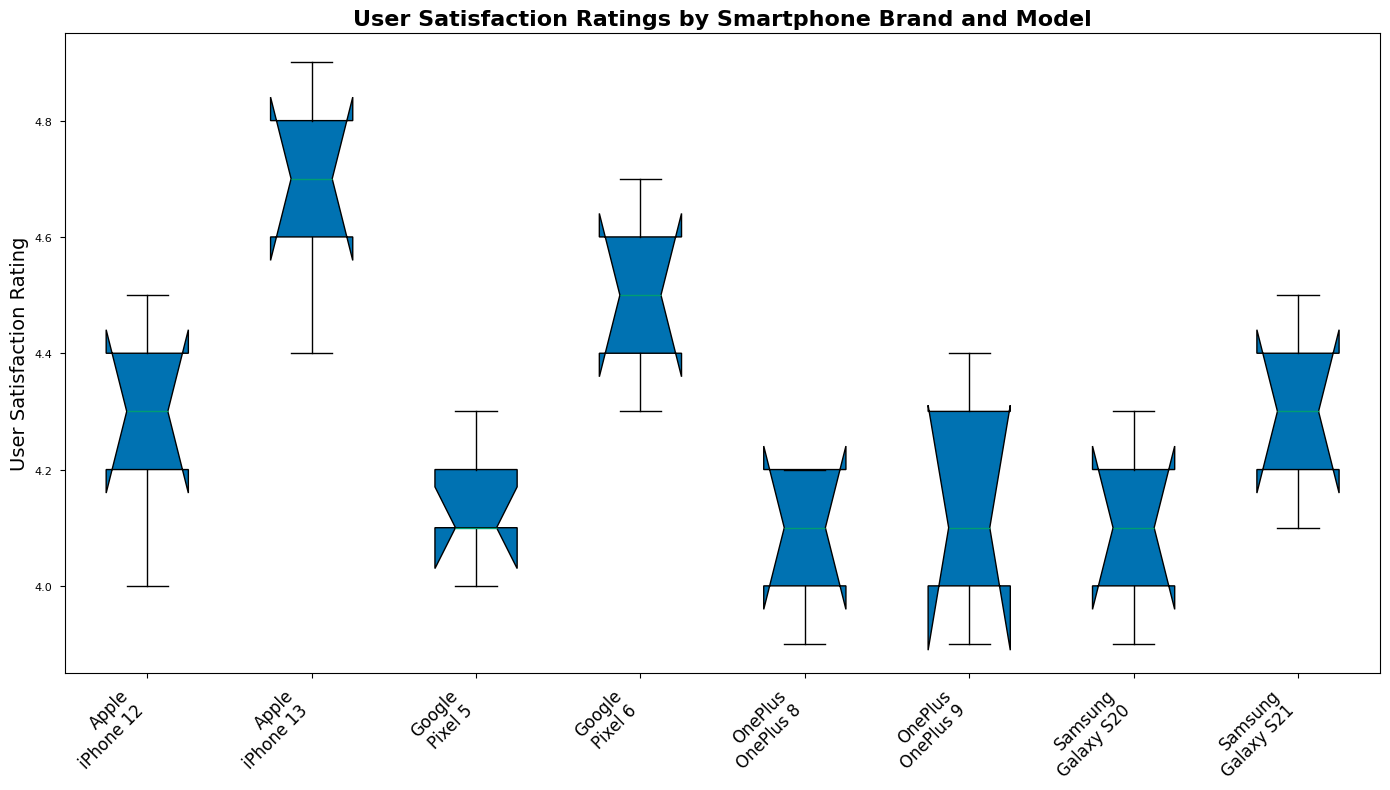What is the median user satisfaction rating for the Pixel 6? To determine the median, look for the middle value in the sorted ratings list for Pixel 6. The ratings are 4.3, 4.4, 4.5, 4.6, and 4.7. The middle value is 4.5.
Answer: 4.5 Which smartphone model has the highest median user satisfaction rating? Compare the median values across all models. The iPhone 13 has the highest median value at 4.7.
Answer: iPhone 13 How does the variation in user satisfaction ratings for the Galaxy S20 compare to the OnePlus 9? Evaluate the interquartile range (IQR) for both models. The Galaxy S20 has an IQR from 4.0 to 4.2, a slight range. The OnePlus 9 has an IQR from 4.1 to 4.3, also small. Both have low variation, but the Galaxy S20 has a slightly narrower range.
Answer: Similar, with Galaxy S20 slightly narrower What is the range of user satisfaction ratings for the iPhone 12? Identify the minimum and maximum values in iPhone 12 ratings. The values are 4.0 (min) and 4.5 (max), so the range is 0.5.
Answer: 0.5 Which brand has the widest distribution of user satisfaction ratings? Evaluate the spread of ratings across all models for each brand visually. OnePlus models (9 and 8) appear to have the widest range indicated by the largest boxes and whiskers in the plot.
Answer: OnePlus Between Pixel 5 and Galaxy S21, which has a higher median user satisfaction rating? Compare the median values of both models. Pixel 5's median is 4.1, while Galaxy S21's median is 4.3.
Answer: Galaxy S21 How do the ratings for the iPhone 13 compare to those of the Pixel 6 in terms of spread and central tendency? The iPhone 13 has a higher median (4.7 vs. 4.5) and slightly less spread/variation as indicated by narrower box plots.
Answer: iPhone 13 has higher median and less spread Which model has the smallest interquartile range (IQR) in user satisfaction ratings? Look for the narrowest box representing the IQR. The iPhone 13 has the smallest IQR.
Answer: iPhone 13 What is the median of the lowest rating and the highest rating for the OnePlus 8? The lowest rating for OnePlus 8 is 3.9, and the highest is 4.2. The median of these two values is (3.9 + 4.2) / 2 = 4.05.
Answer: 4.05 Which smartphone model shows the most consistent user satisfaction ratings? Consistency implies a small range and IQR. The iPhone 13, with the least variation and smallest IQR, is the most consistent.
Answer: iPhone 13 